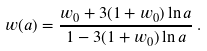Convert formula to latex. <formula><loc_0><loc_0><loc_500><loc_500>w ( a ) = \frac { w _ { 0 } + 3 ( 1 + w _ { 0 } ) \ln a } { 1 - 3 ( 1 + w _ { 0 } ) \ln a } \, .</formula> 